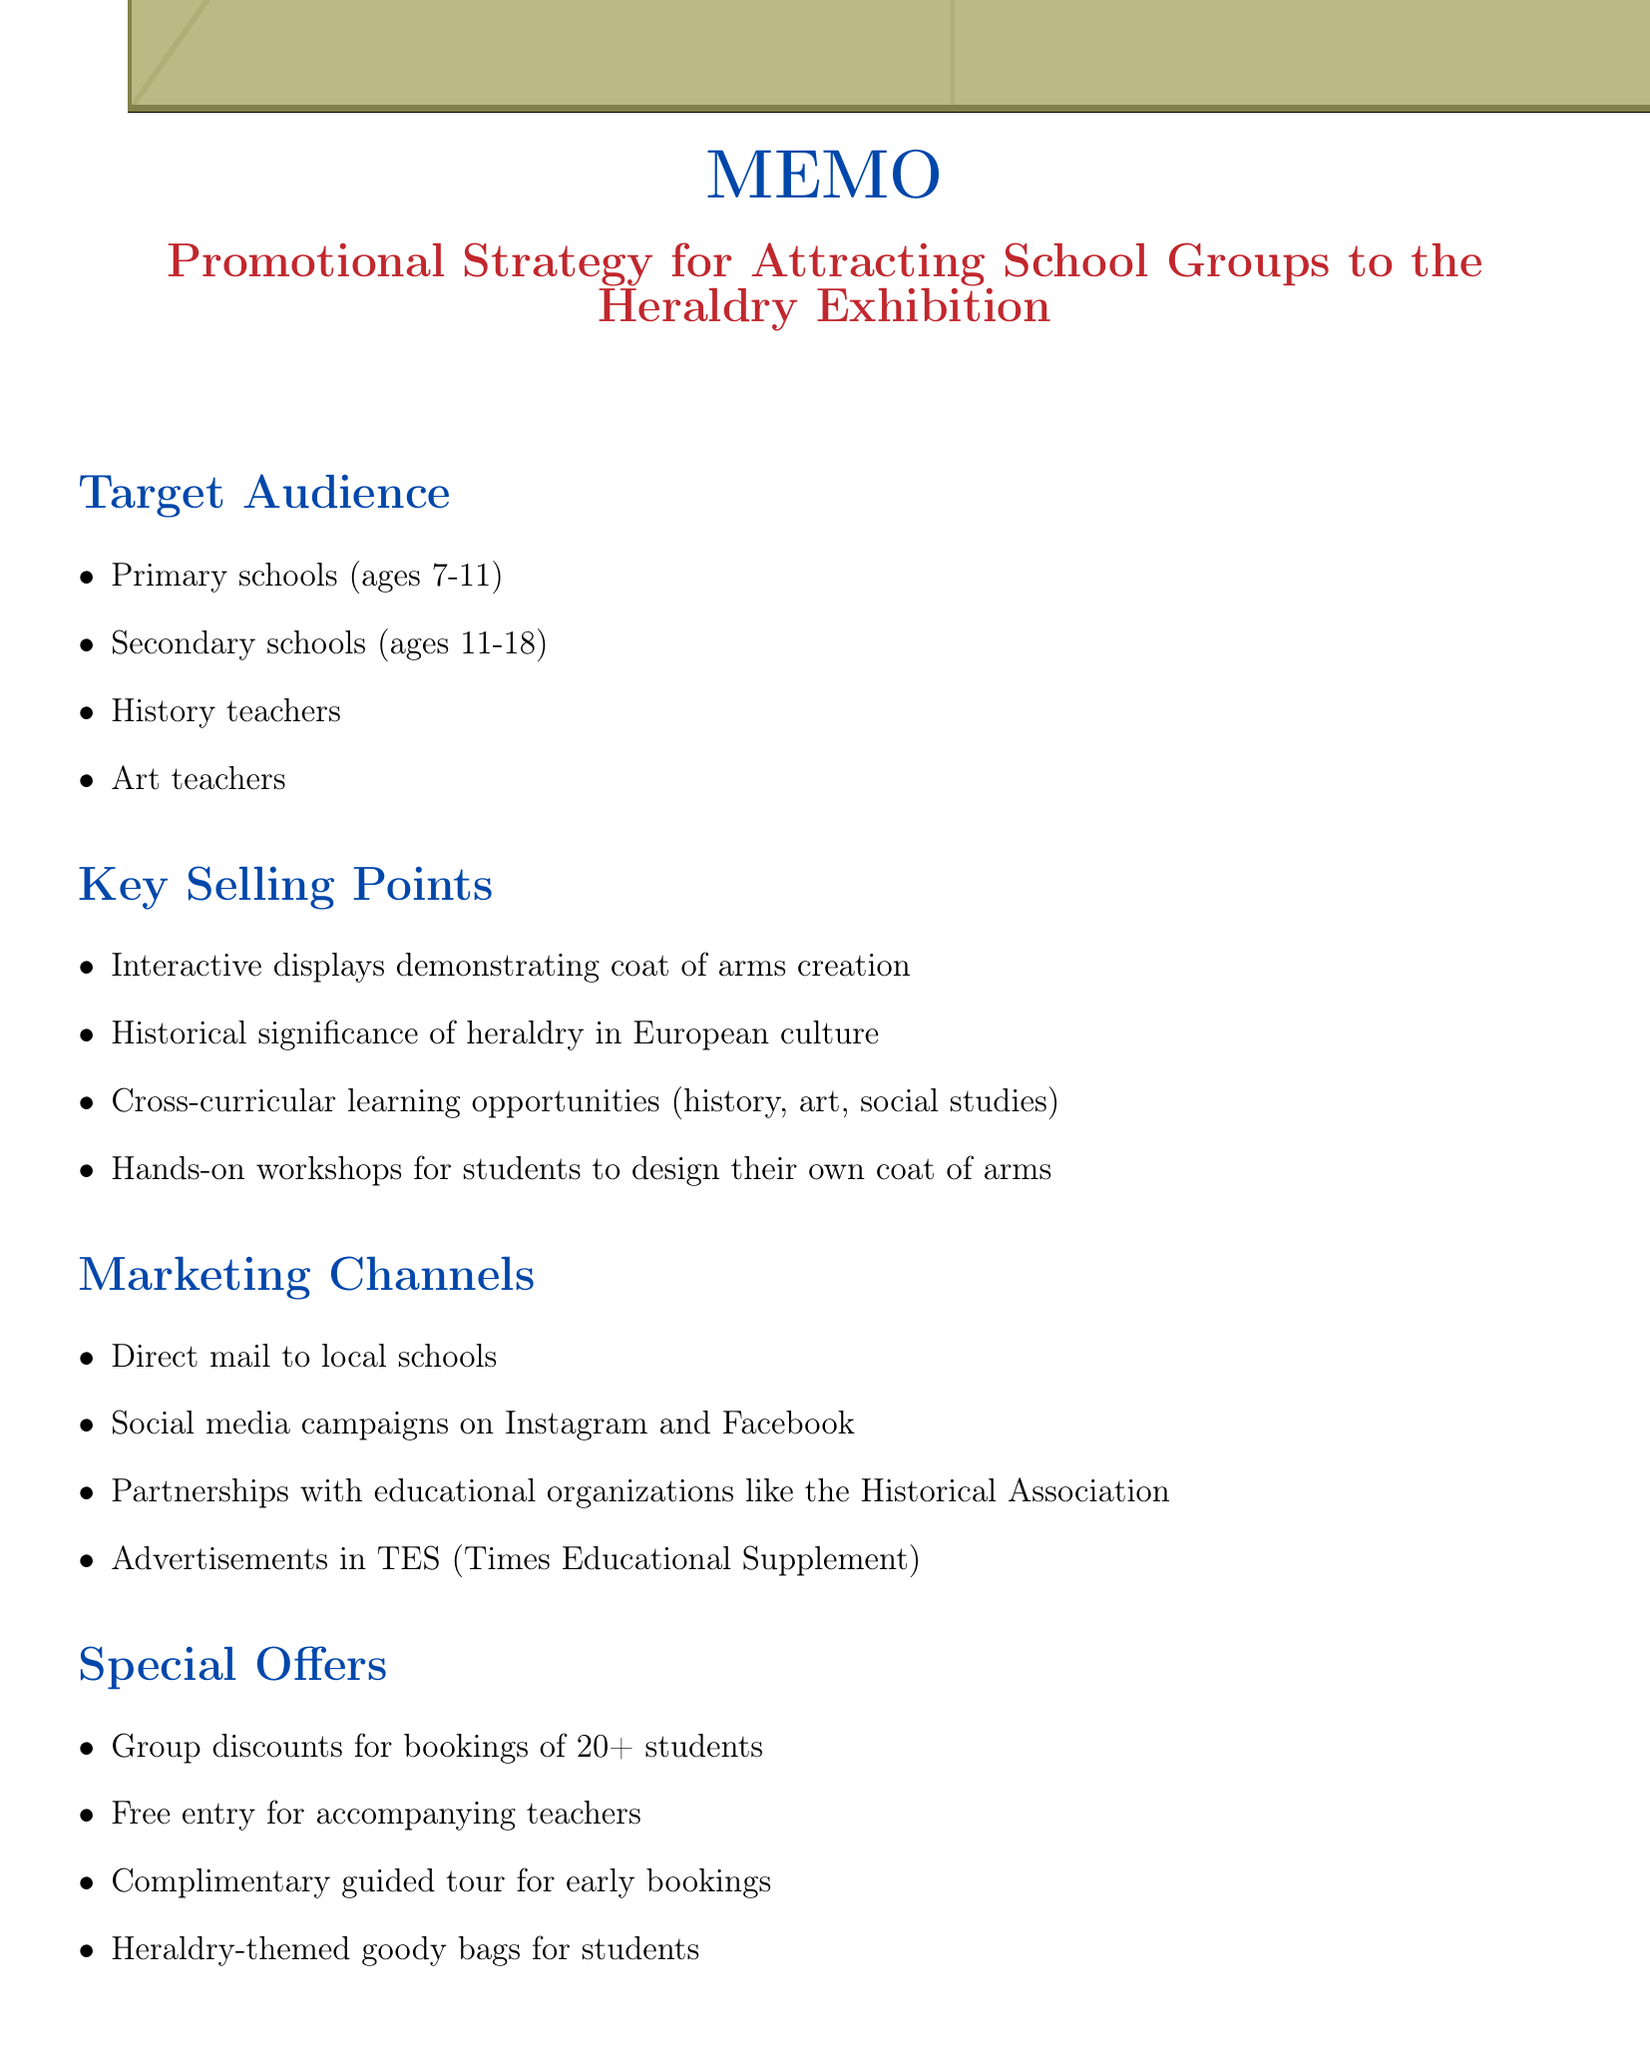What is the title of the memo? The title can be found at the beginning of the memo, clearly stating the promotional strategy.
Answer: Promotional Strategy for Attracting School Groups to the Heraldry Exhibition What is one of the key selling points? Key selling points are listed under their own section, showcasing the main attractions for school groups.
Answer: Interactive displays demonstrating coat of arms creation What is the date for launching the promotional campaign? The timeline section provides important dates related to the promotional strategy.
Answer: September 1, 2023 What is the budget allocated for digital advertising? The budget allocation section lists specific allocations for various promotional activities.
Answer: £7,500 How many students must be in a group to qualify for discounts? The special offers section specifies the minimum number of students required for group discounts.
Answer: 20+ Who is the guest lecturer mentioned in the collaborations? The collaborations section highlights partnerships and guest lectures related to the exhibition.
Answer: Dr. Richard Fitzwilliam What educational resource is available for teachers? The educational resources section describes supports offered to facilitate teacher involvement.
Answer: Pre-visit lesson plans aligned with National Curriculum What is the success metric related to social media? Success metrics measure the effectiveness of the promotional strategy, including social media performance.
Answer: Social media engagement and shares When is the exhibition opening day? The timeline section provides the specific date when the exhibition will open to the public.
Answer: January 10, 2024 